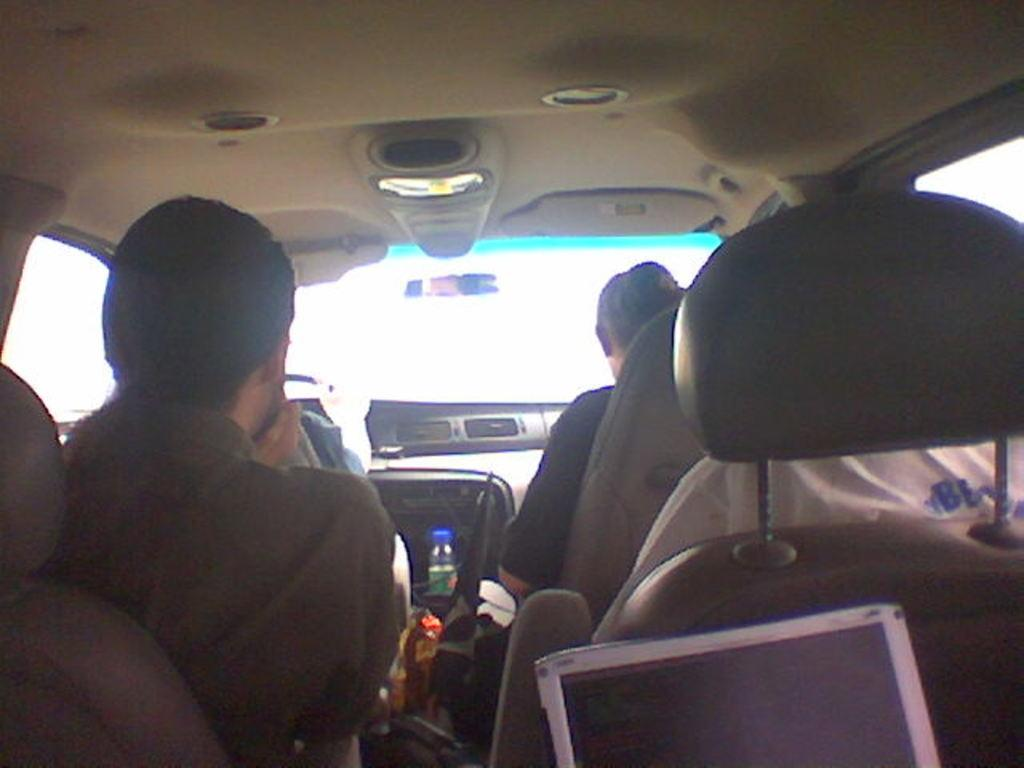What is happening in the image? There are people inside a vehicle in the image. Can you describe any objects visible in the image? Yes, there is a bottle visible in the image. What type of prose is being read by the people in the image? There is no indication in the image that the people are reading any prose, as the focus is on their presence inside the vehicle and the visible bottle. 